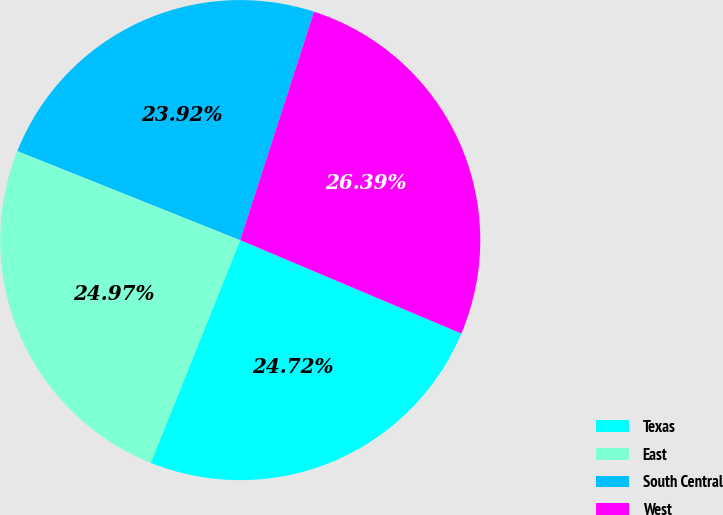Convert chart. <chart><loc_0><loc_0><loc_500><loc_500><pie_chart><fcel>Texas<fcel>East<fcel>South Central<fcel>West<nl><fcel>24.72%<fcel>24.97%<fcel>23.92%<fcel>26.39%<nl></chart> 